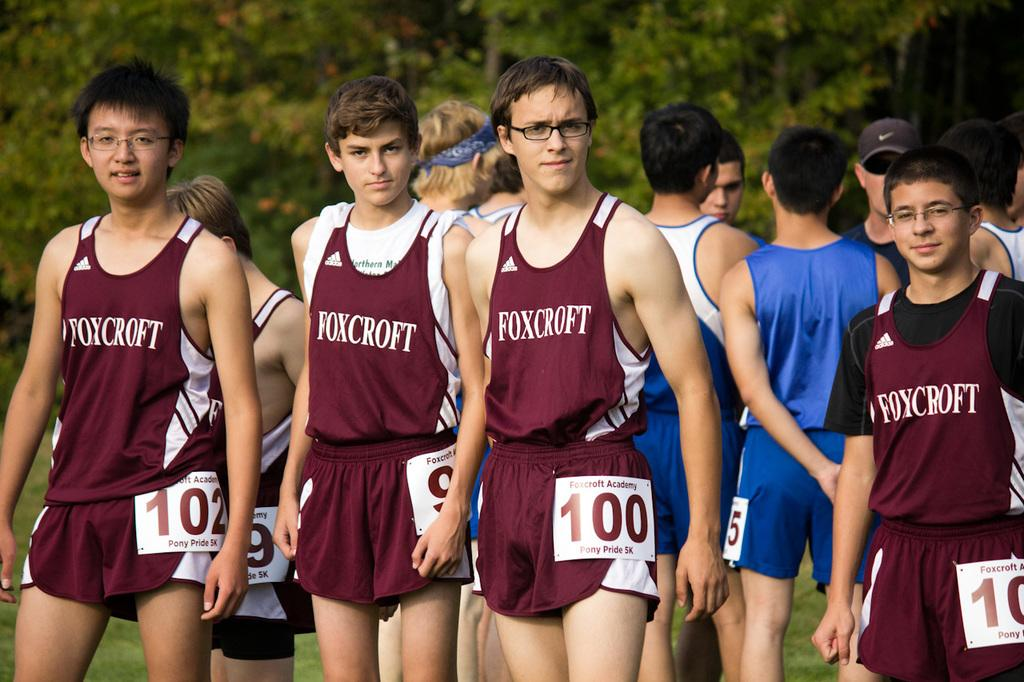<image>
Render a clear and concise summary of the photo. a team of young men are lined up to run a race for the Foxcroft school 